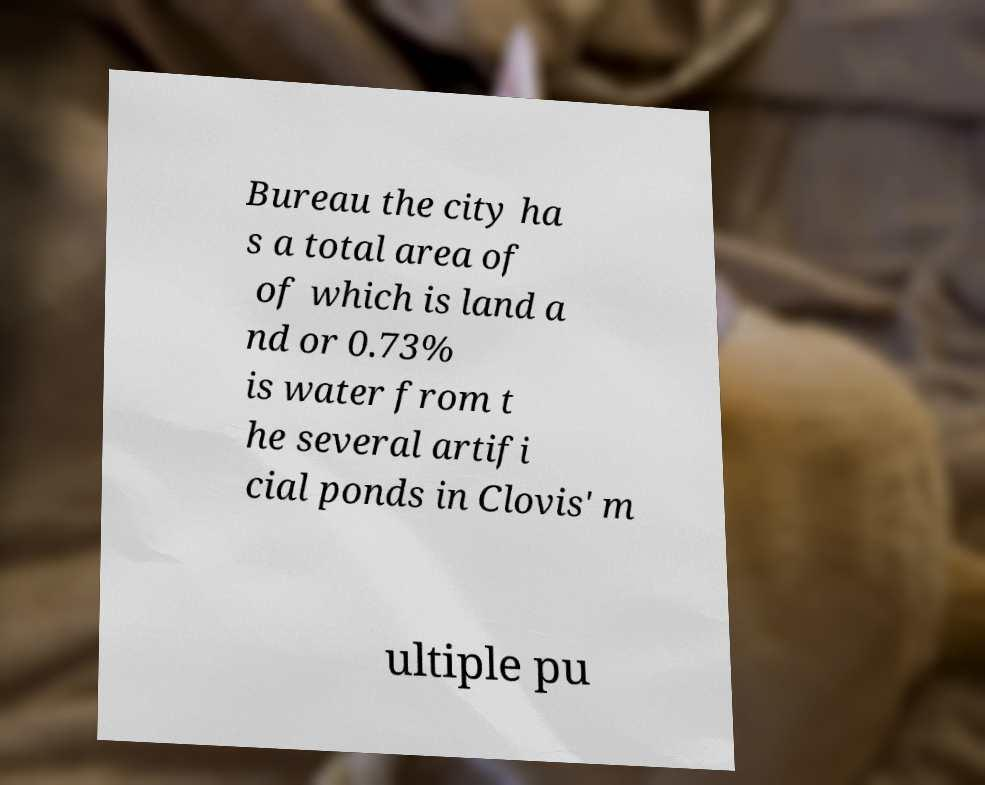There's text embedded in this image that I need extracted. Can you transcribe it verbatim? Bureau the city ha s a total area of of which is land a nd or 0.73% is water from t he several artifi cial ponds in Clovis' m ultiple pu 